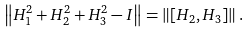<formula> <loc_0><loc_0><loc_500><loc_500>\left \| H _ { 1 } ^ { 2 } + H _ { 2 } ^ { 2 } + H _ { 3 } ^ { 2 } - I \right \| & = \left \| \left [ H _ { 2 } , H _ { 3 } \right ] \right \| .</formula> 